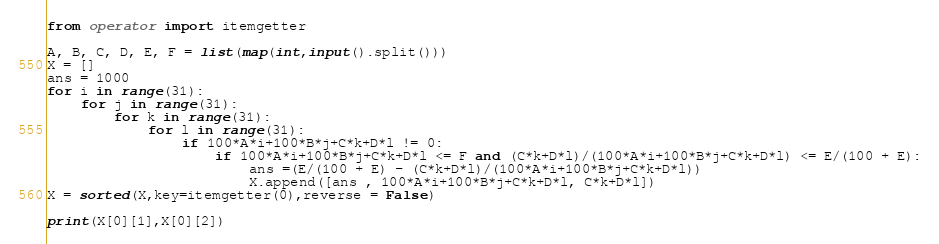<code> <loc_0><loc_0><loc_500><loc_500><_Python_>from operator import itemgetter

A, B, C, D, E, F = list(map(int,input().split()))
X = []
ans = 1000
for i in range(31):
    for j in range(31):
        for k in range(31):
            for l in range(31):
                if 100*A*i+100*B*j+C*k+D*l != 0:
                    if 100*A*i+100*B*j+C*k+D*l <= F and (C*k+D*l)/(100*A*i+100*B*j+C*k+D*l) <= E/(100 + E):
                        ans =(E/(100 + E) - (C*k+D*l)/(100*A*i+100*B*j+C*k+D*l))
                        X.append([ans , 100*A*i+100*B*j+C*k+D*l, C*k+D*l])
X = sorted(X,key=itemgetter(0),reverse = False) 

print(X[0][1],X[0][2])</code> 